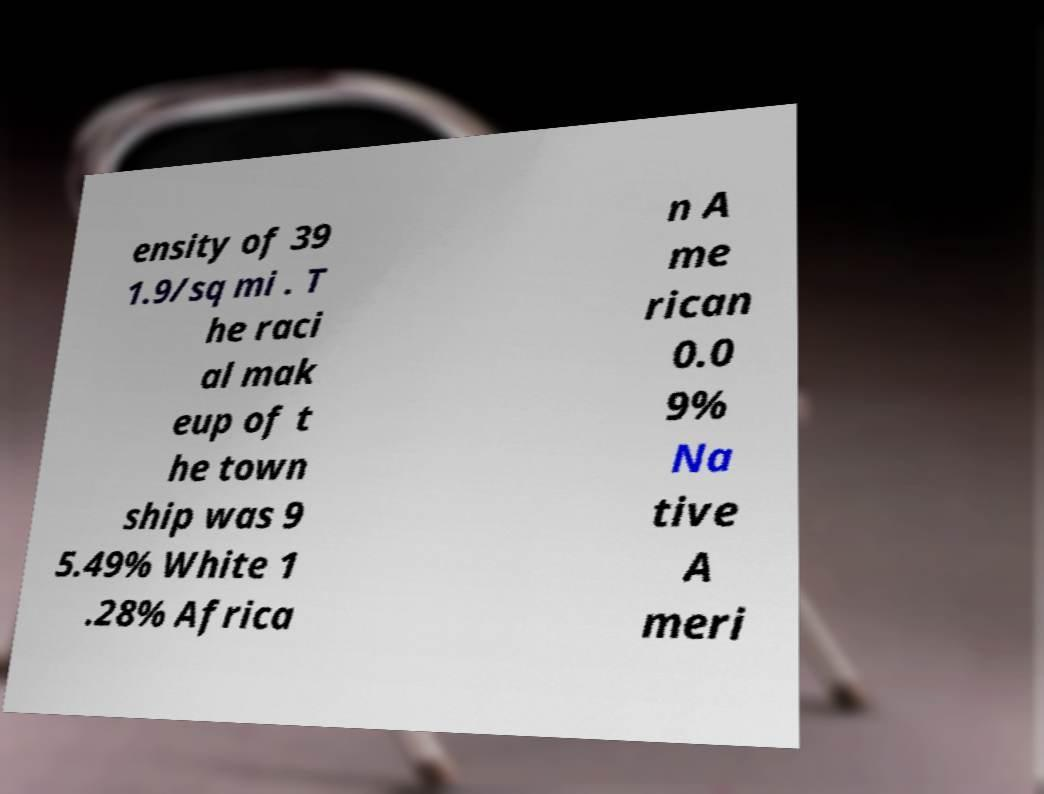What messages or text are displayed in this image? I need them in a readable, typed format. ensity of 39 1.9/sq mi . T he raci al mak eup of t he town ship was 9 5.49% White 1 .28% Africa n A me rican 0.0 9% Na tive A meri 